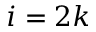<formula> <loc_0><loc_0><loc_500><loc_500>i = 2 k</formula> 